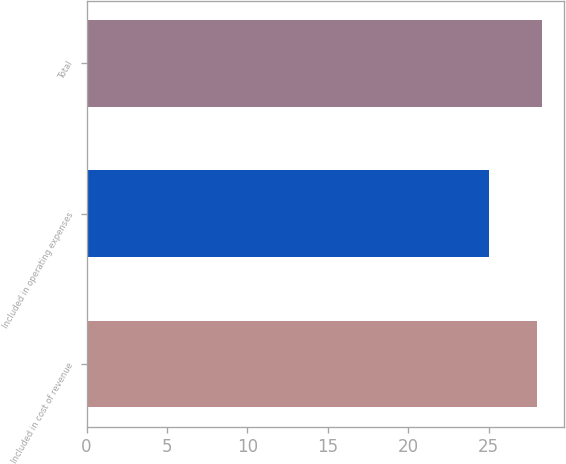Convert chart to OTSL. <chart><loc_0><loc_0><loc_500><loc_500><bar_chart><fcel>Included in cost of revenue<fcel>Included in operating expenses<fcel>Total<nl><fcel>28<fcel>25<fcel>28.3<nl></chart> 